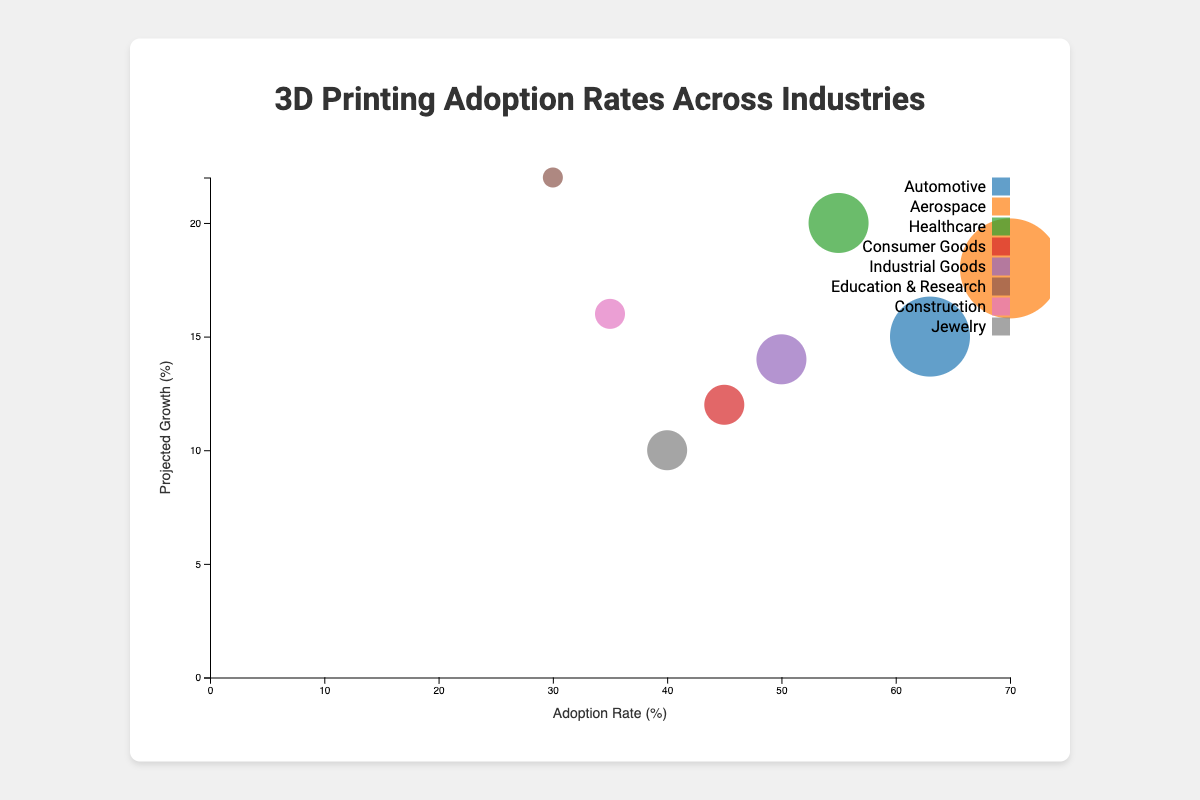What is the title of the chart? The title is usually located at the top of the chart and displays the main subject of the visualization. The title here is "3D Printing Adoption Rates Across Industries".
Answer: "3D Printing Adoption Rates Across Industries" What are the labels for the X and Y axes? The labels for the axes give the units or categories that the data is plotted against. By inspecting the chart, we can see that the X-axis is labeled "Adoption Rate (%)" and the Y-axis is labeled "Projected Growth (%)".
Answer: "Adoption Rate (%)" for X and "Projected Growth (%)" for Y Which industry has the highest adoption rate of 3D printing? Look at the bubbles and find the one that extends the furthest along the X-axis. The industry that corresponds to the highest adoption rate of 70% is Aerospace.
Answer: Aerospace How many industries have a projected growth rate of 20% or higher? Check the Y-axis and count the bubbles that are positioned at 20% or higher. Only Healthcare (20%) and Education & Research (22%) meet this criterion.
Answer: 2 What is the adoption rate and projected growth for the Healthcare industry? Find the bubble labeled Healthcare, and note both its X-axis (Adoption Rate) and Y-axis (Projected Growth) positions. The Healthcare industry has an adoption rate of 55% and a projected growth of 20%.
Answer: Adoption rate: 55%, Projected growth: 20% Which industry has the largest bubble size in this chart? Look for the bubble that appears the largest due to its size attribute. The Aerospace industry has the largest bubble with a size of 90.
Answer: Aerospace Compare the adoption rate and projected growth of the Construction and Jewelry industries. Which one has a greater adoption rate and which one has a higher projected growth? Compare the X and Y positions of the Construction and Jewelry bubbles. Construction has an adoption rate of 35% and projected growth of 16%, while Jewelry has an adoption rate of 40% and projected growth of 10%. Jewelry has a greater adoption rate, but Construction has a higher projected growth.
Answer: Jewelry has a greater adoption rate, Construction has a higher projected growth What is the average adoption rate of Jewelry and Consumer Goods industries? Add the adoption rates of Jewelry (40%) and Consumer Goods (45%), then divide by 2. (40 + 45) / 2 = 42.5%
Answer: 42.5% Which industry has the smallest bubble size and what is its adoption rate and projected growth? Identify the bubble with the smallest size, which is 50. The industry is Education & Research with an adoption rate of 30% and projected growth of 22%.
Answer: Education & Research, Adoption Rate: 30%, Projected Growth: 22% Between Automotive and Aerospace industries, which has a higher projected growth and by how much? Compare the Y-axis positions of the Automotive and Aerospace bubbles. Automotive has a projected growth of 15%, while Aerospace has 18%. The difference is 18% - 15% = 3%.
Answer: Aerospace by 3% 